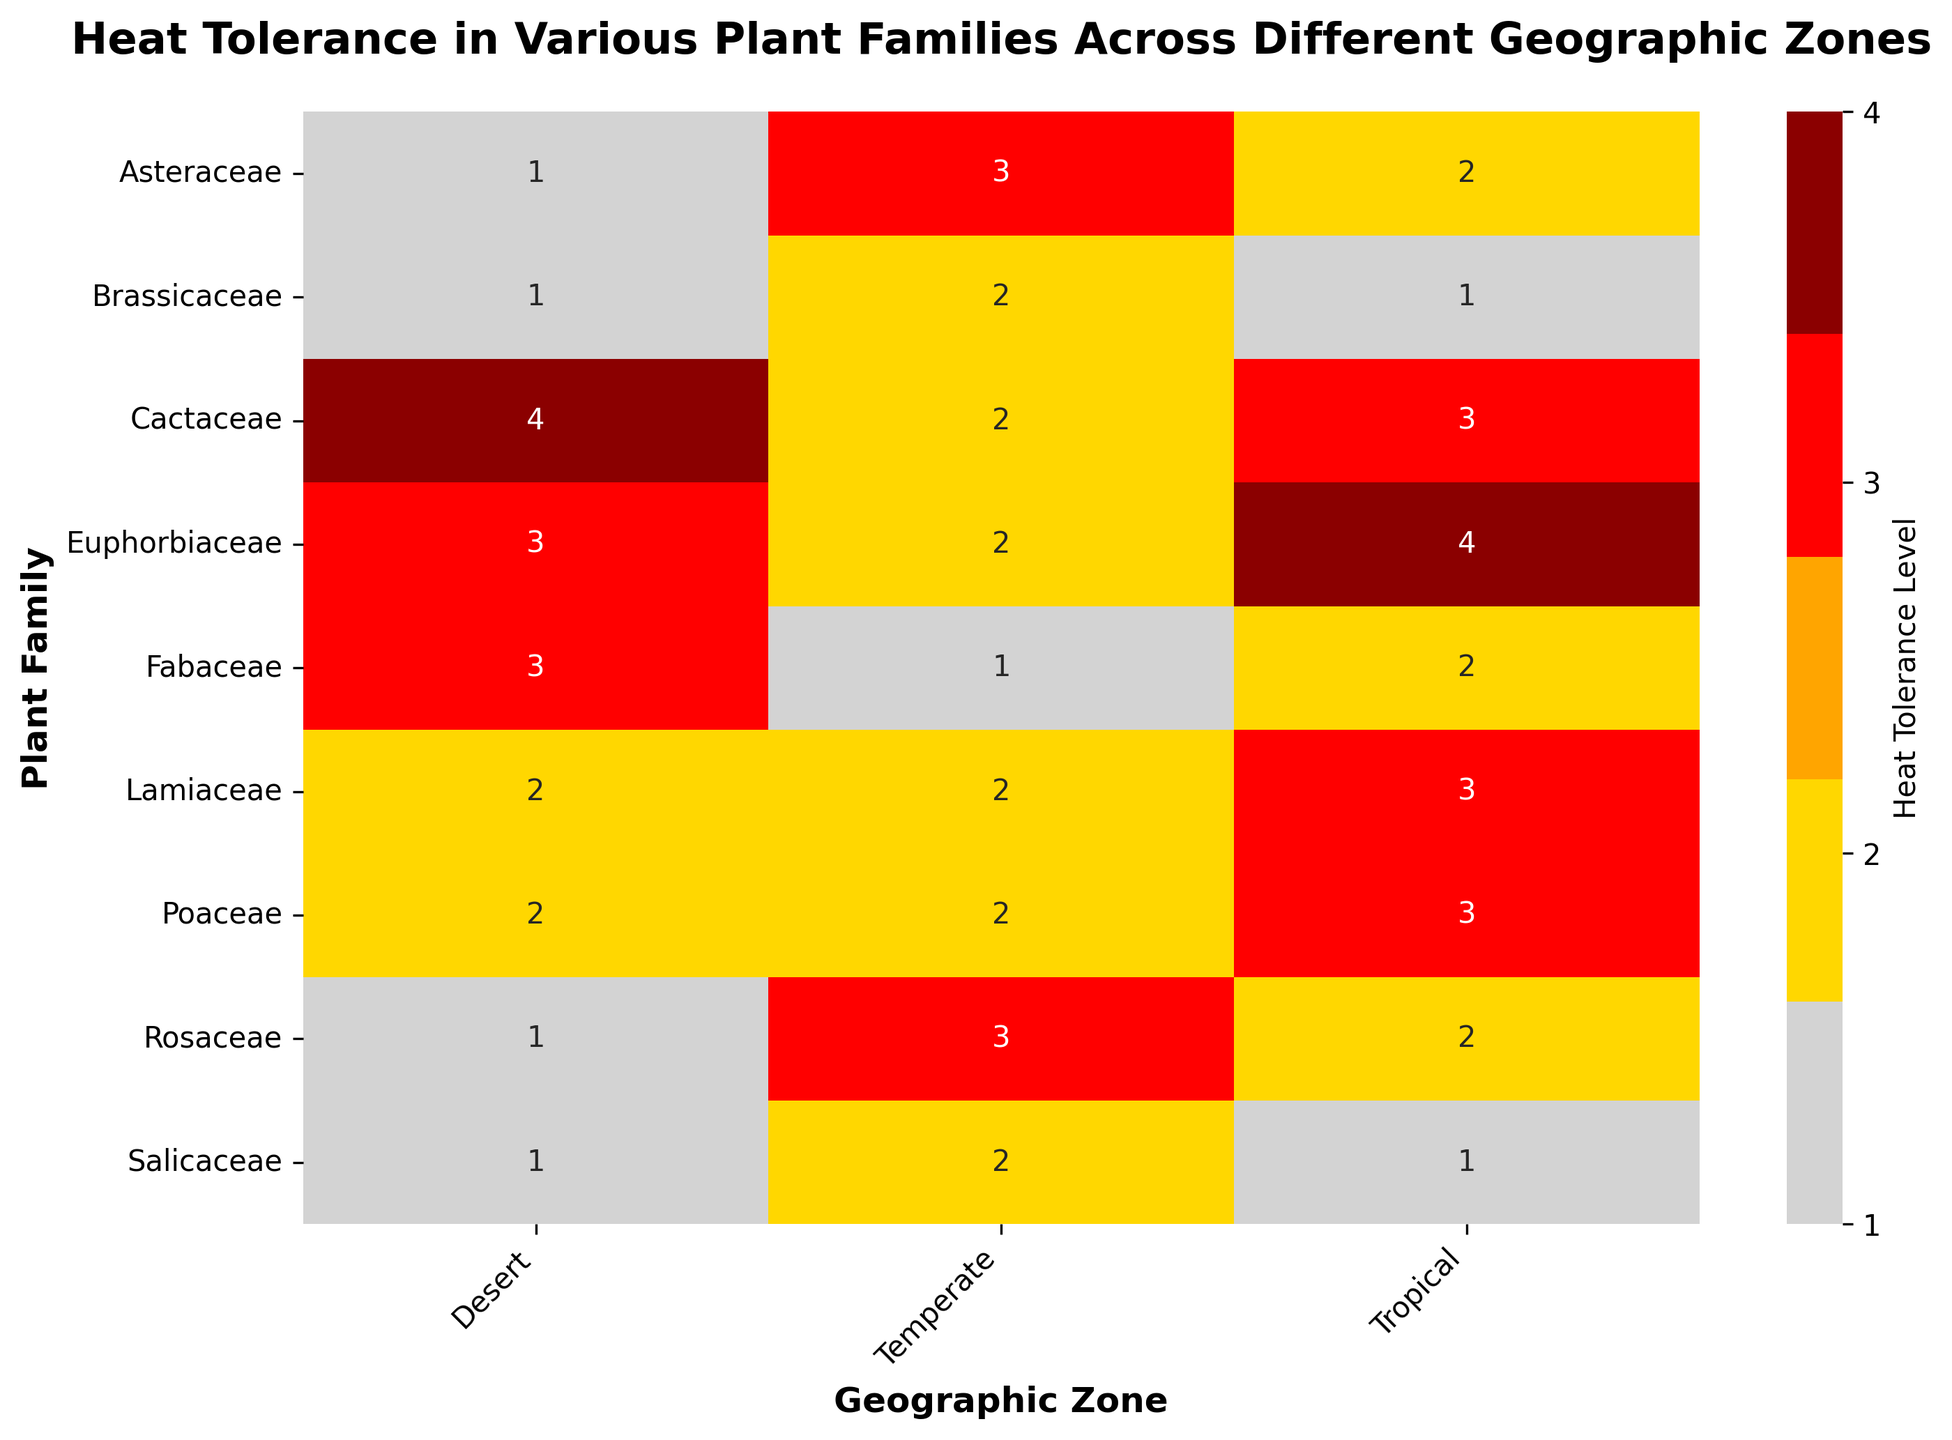What is the heat tolerance level of the Fabaceae family in the Desert zone? Look at the intersection of the Fabaceae row and the Desert column. The heat tolerance level indicated is High.
Answer: High Which plant family shows the highest heat tolerance in the Tropical zone? Look at the Tropical column and find the cell with the highest heat tolerance level (darkred for Very High). The plant family with Very High heat tolerance in this zone is Euphorbiaceae.
Answer: Euphorbiaceae How does the heat tolerance of the Poaceae family in the Temperate zone compare to that in the Desert zone? Examine the heat tolerance levels for Poaceae in both the Temperate and Desert zones. The value for the Desert zone is Medium, while for the Temperate zone it is also Medium. Thus, the tolerance levels are equal.
Answer: Equal Which geographic zone has the most variety in heat tolerance levels among plant families? Review the heatmap for observed range of colors (from lightgray for Low to darkred for Very High) within each geographic zone column. The Desert zone shows the colors ranging from lightgray to darkred, indicating the widest variety of heat tolerance.
Answer: Desert How many plant families have a Medium heat tolerance in the Desrt zone? Count the number of cells colored orange in the Desert zone column, corresponding to Medium heat tolerance. The plant families include Poaceae and Lamiaceae, totaling two.
Answer: 2 What is the average heat tolerance level of the Rosaceae family across all geographic zones? Convert the heat tolerance levels for the Rosaceae family (Desert: Low, Tropical: Medium, Temperate: High) into their numeric equivalents (1, 2, 3). Calculate the average: (1 + 2 + 3) / 3 = 2.0, corresponding to Medium.
Answer: Medium Which plant family has the least heat tolerance in both the Desert and Temperate zones? Look for the lowest heat tolerance level (lightgray for Low) in both Desert and Temperate zone columns. The Brassicaceae family has Low tolerance in both zones.
Answer: Brassicaceae Is there a plant family with a Very High heat tolerance across all geographic zones? Scan each cell across all zones for every plant family. Only the Cactaceae family reaches Very High in the Desert zone but not in all zones. So the answer is none.
Answer: None What is the sum of the numeric heat tolerance levels for the Lamiaceae family across all zones? Convert the Lamiaceae family's heat tolerance levels (Desert: Medium, Tropical: High, Temperate: Medium) into their numeric equivalents (2, 3, 2). Sum these values: 2 + 3 + 2 = 7.
Answer: 7 How many geographic zones does Asteraceae have a heat tolerance level higher than Medium? Check the values for Asteraceae in all geographic zones. The Tropical zone shows Medium (orange), while only the Temperate zone has High (red), which is higher than Medium. So, the Asteraceae family has a higher heat tolerance in one zone.
Answer: 1 